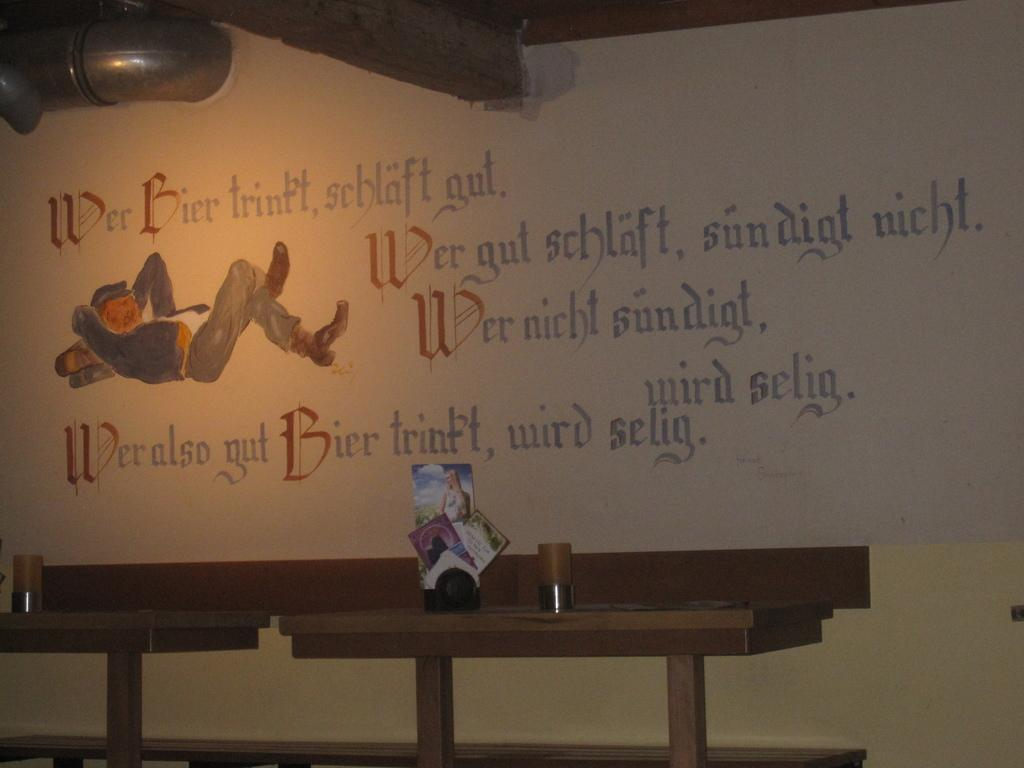<image>
Provide a brief description of the given image. A large board with German calligraphy writing on it and an image of a man laying down. 